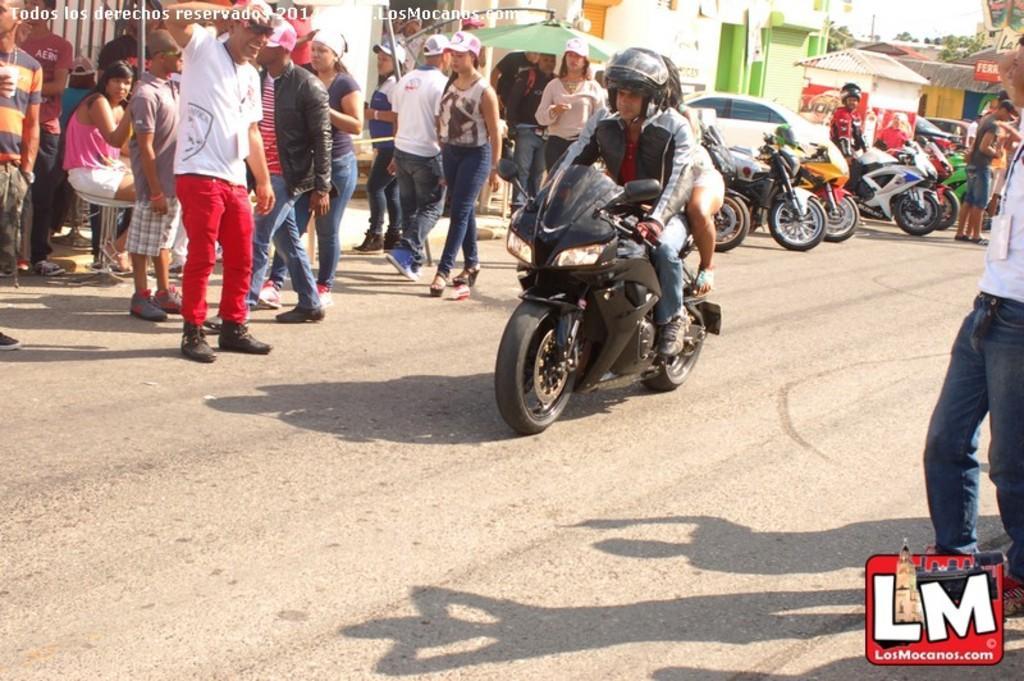Describe this image in one or two sentences. In this image I see a man and a woman who are sitting on the bike and there are lot of people over here and few of them are wearing caps. In the background I see the bikes, car. few buildings. 